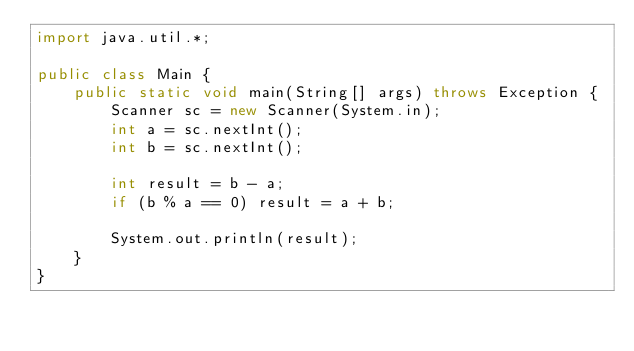Convert code to text. <code><loc_0><loc_0><loc_500><loc_500><_Java_>import java.util.*;

public class Main {
    public static void main(String[] args) throws Exception {
        Scanner sc = new Scanner(System.in);
        int a = sc.nextInt();
        int b = sc.nextInt();
      
        int result = b - a;
        if (b % a == 0) result = a + b;
        
        System.out.println(result);
    }
}
</code> 